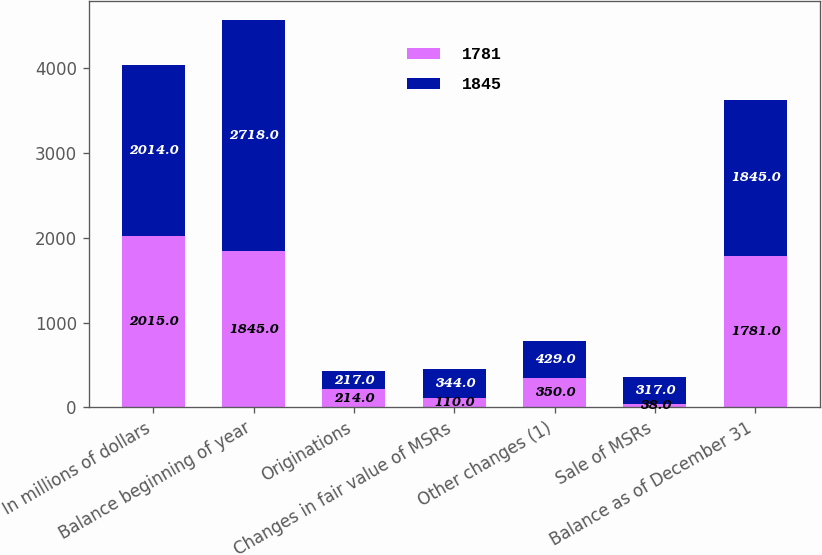Convert chart. <chart><loc_0><loc_0><loc_500><loc_500><stacked_bar_chart><ecel><fcel>In millions of dollars<fcel>Balance beginning of year<fcel>Originations<fcel>Changes in fair value of MSRs<fcel>Other changes (1)<fcel>Sale of MSRs<fcel>Balance as of December 31<nl><fcel>1781<fcel>2015<fcel>1845<fcel>214<fcel>110<fcel>350<fcel>38<fcel>1781<nl><fcel>1845<fcel>2014<fcel>2718<fcel>217<fcel>344<fcel>429<fcel>317<fcel>1845<nl></chart> 